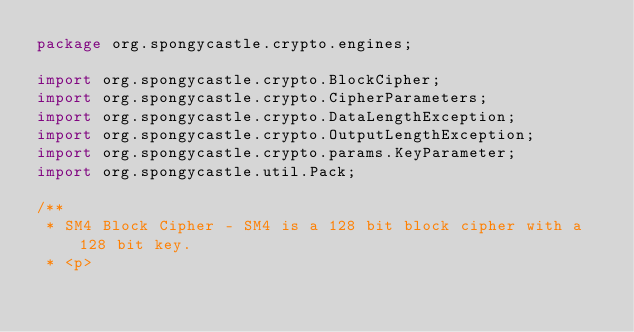<code> <loc_0><loc_0><loc_500><loc_500><_Java_>package org.spongycastle.crypto.engines;

import org.spongycastle.crypto.BlockCipher;
import org.spongycastle.crypto.CipherParameters;
import org.spongycastle.crypto.DataLengthException;
import org.spongycastle.crypto.OutputLengthException;
import org.spongycastle.crypto.params.KeyParameter;
import org.spongycastle.util.Pack;

/**
 * SM4 Block Cipher - SM4 is a 128 bit block cipher with a 128 bit key.
 * <p></code> 